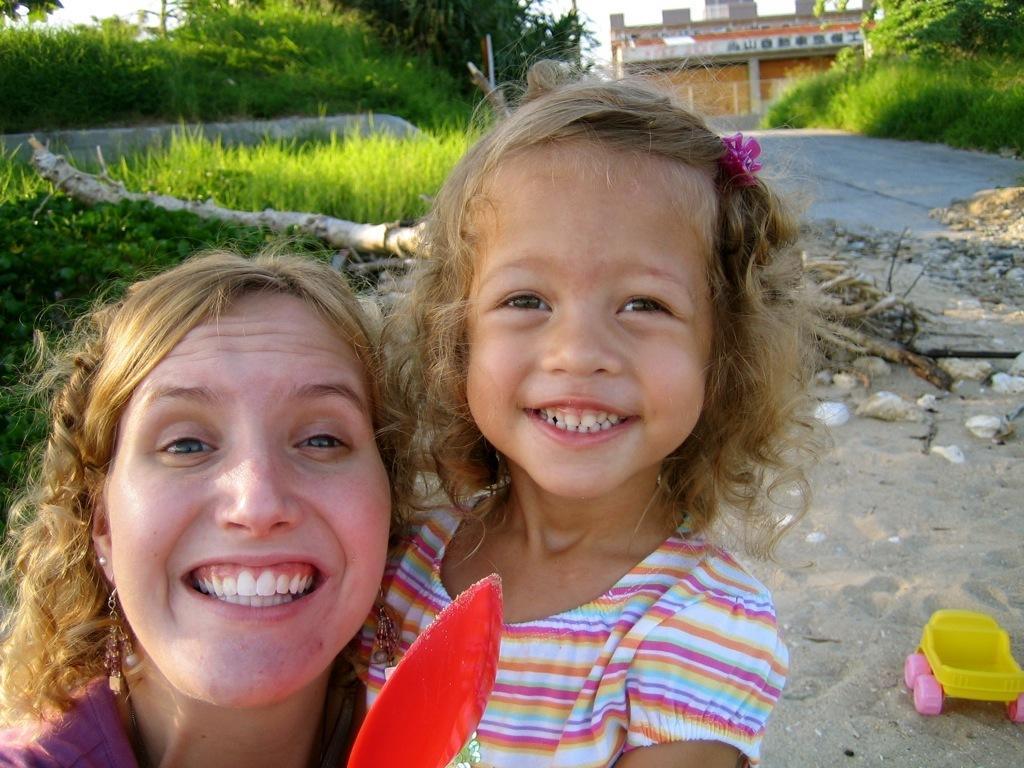In one or two sentences, can you explain what this image depicts? On the left side of the image there is a lady smiling. Beside her there is a girl smiling. Behind them on the ground there is grass, wooden log and also there are small plants. On the right side of the image on the ground there is sand with a toy and stones. In the background there are trees and also there is a building. 